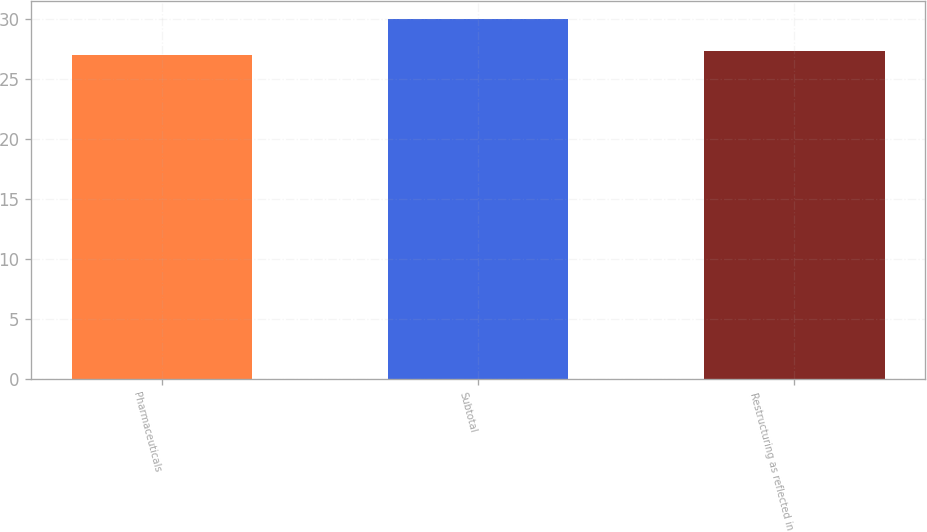Convert chart. <chart><loc_0><loc_0><loc_500><loc_500><bar_chart><fcel>Pharmaceuticals<fcel>Subtotal<fcel>Restructuring as reflected in<nl><fcel>27<fcel>30<fcel>27.3<nl></chart> 